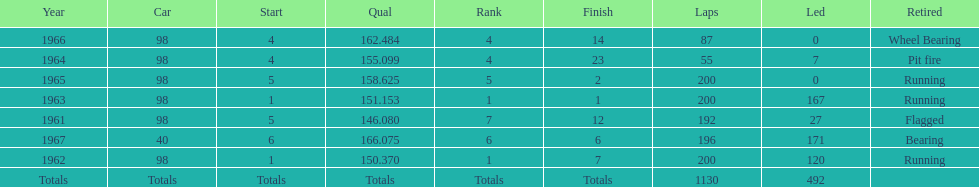Number of instances to conclude the races by running. 3. 